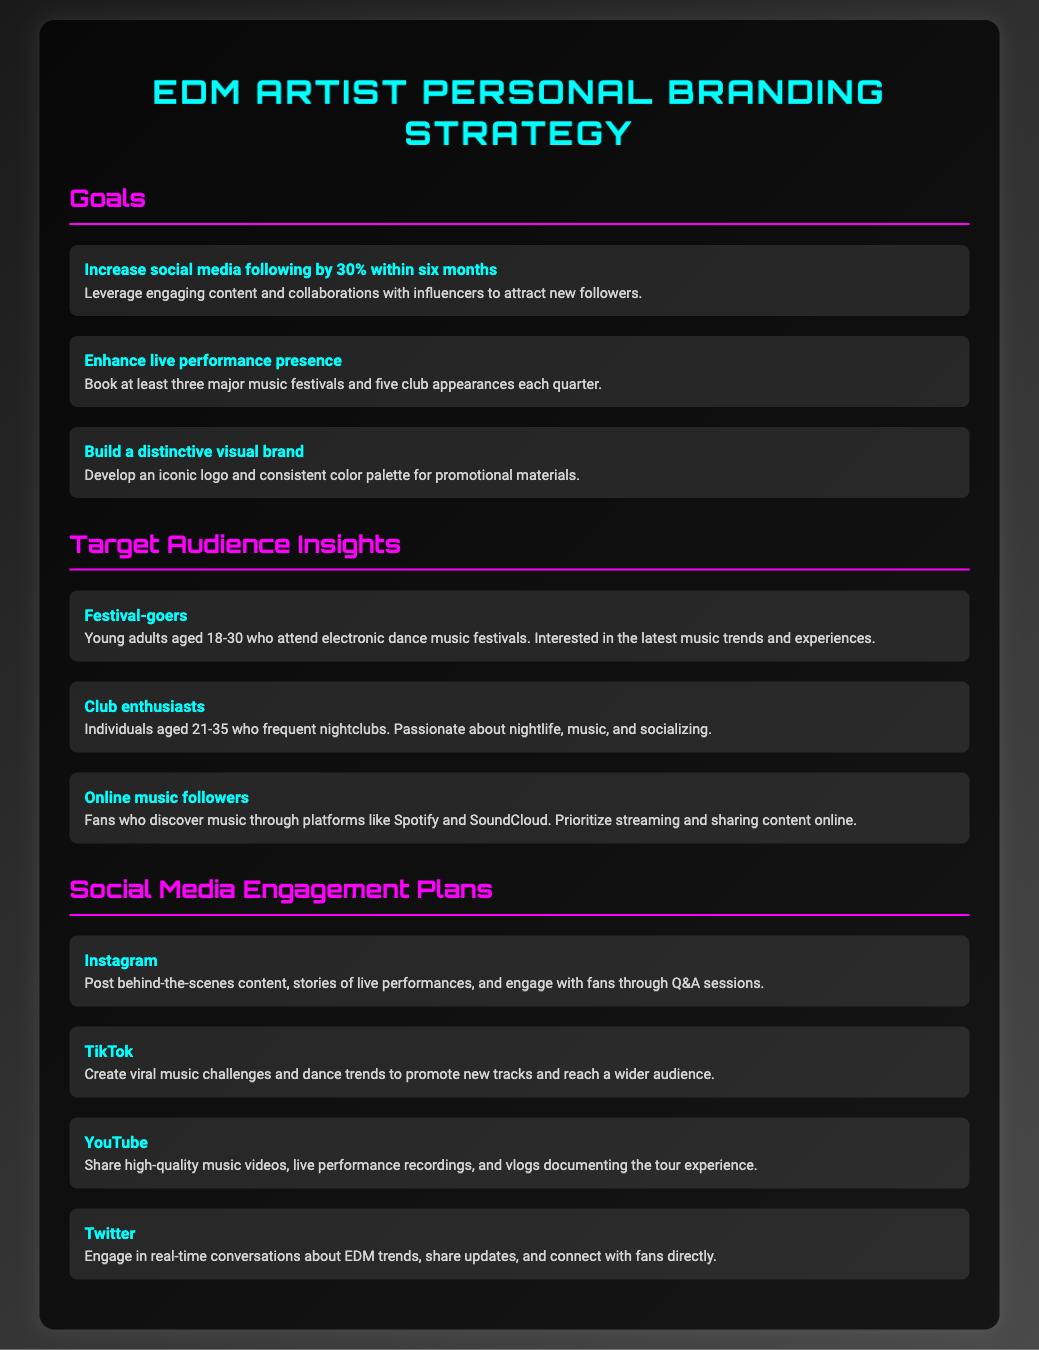what is the goal for increasing social media following? The document states a goal to increase social media following by 30% within six months.
Answer: 30% how many music festivals does the strategy aim to book each quarter? The document specifies booking at least three major music festivals each quarter.
Answer: three who is the target audience aged 18-30? The target audience described for this age group is festival-goers.
Answer: festival-goers which social media platform plans to feature high-quality music videos? The engagement plan mentions sharing high-quality music videos on YouTube.
Answer: YouTube what is the target age range for club enthusiasts? The target age range specified for club enthusiasts is 21-35.
Answer: 21-35 what type of content is planned for Instagram? The document describes posting behind-the-scenes content on Instagram.
Answer: behind-the-scenes content how many club appearances are targeted each quarter? The strategy aims for five club appearances each quarter.
Answer: five which platform is mentioned for creating viral music challenges? The plan mentions creating viral music challenges on TikTok.
Answer: TikTok what color is used for the headings in the document? The document uses a color code for headings that is #ff00ff.
Answer: #ff00ff 